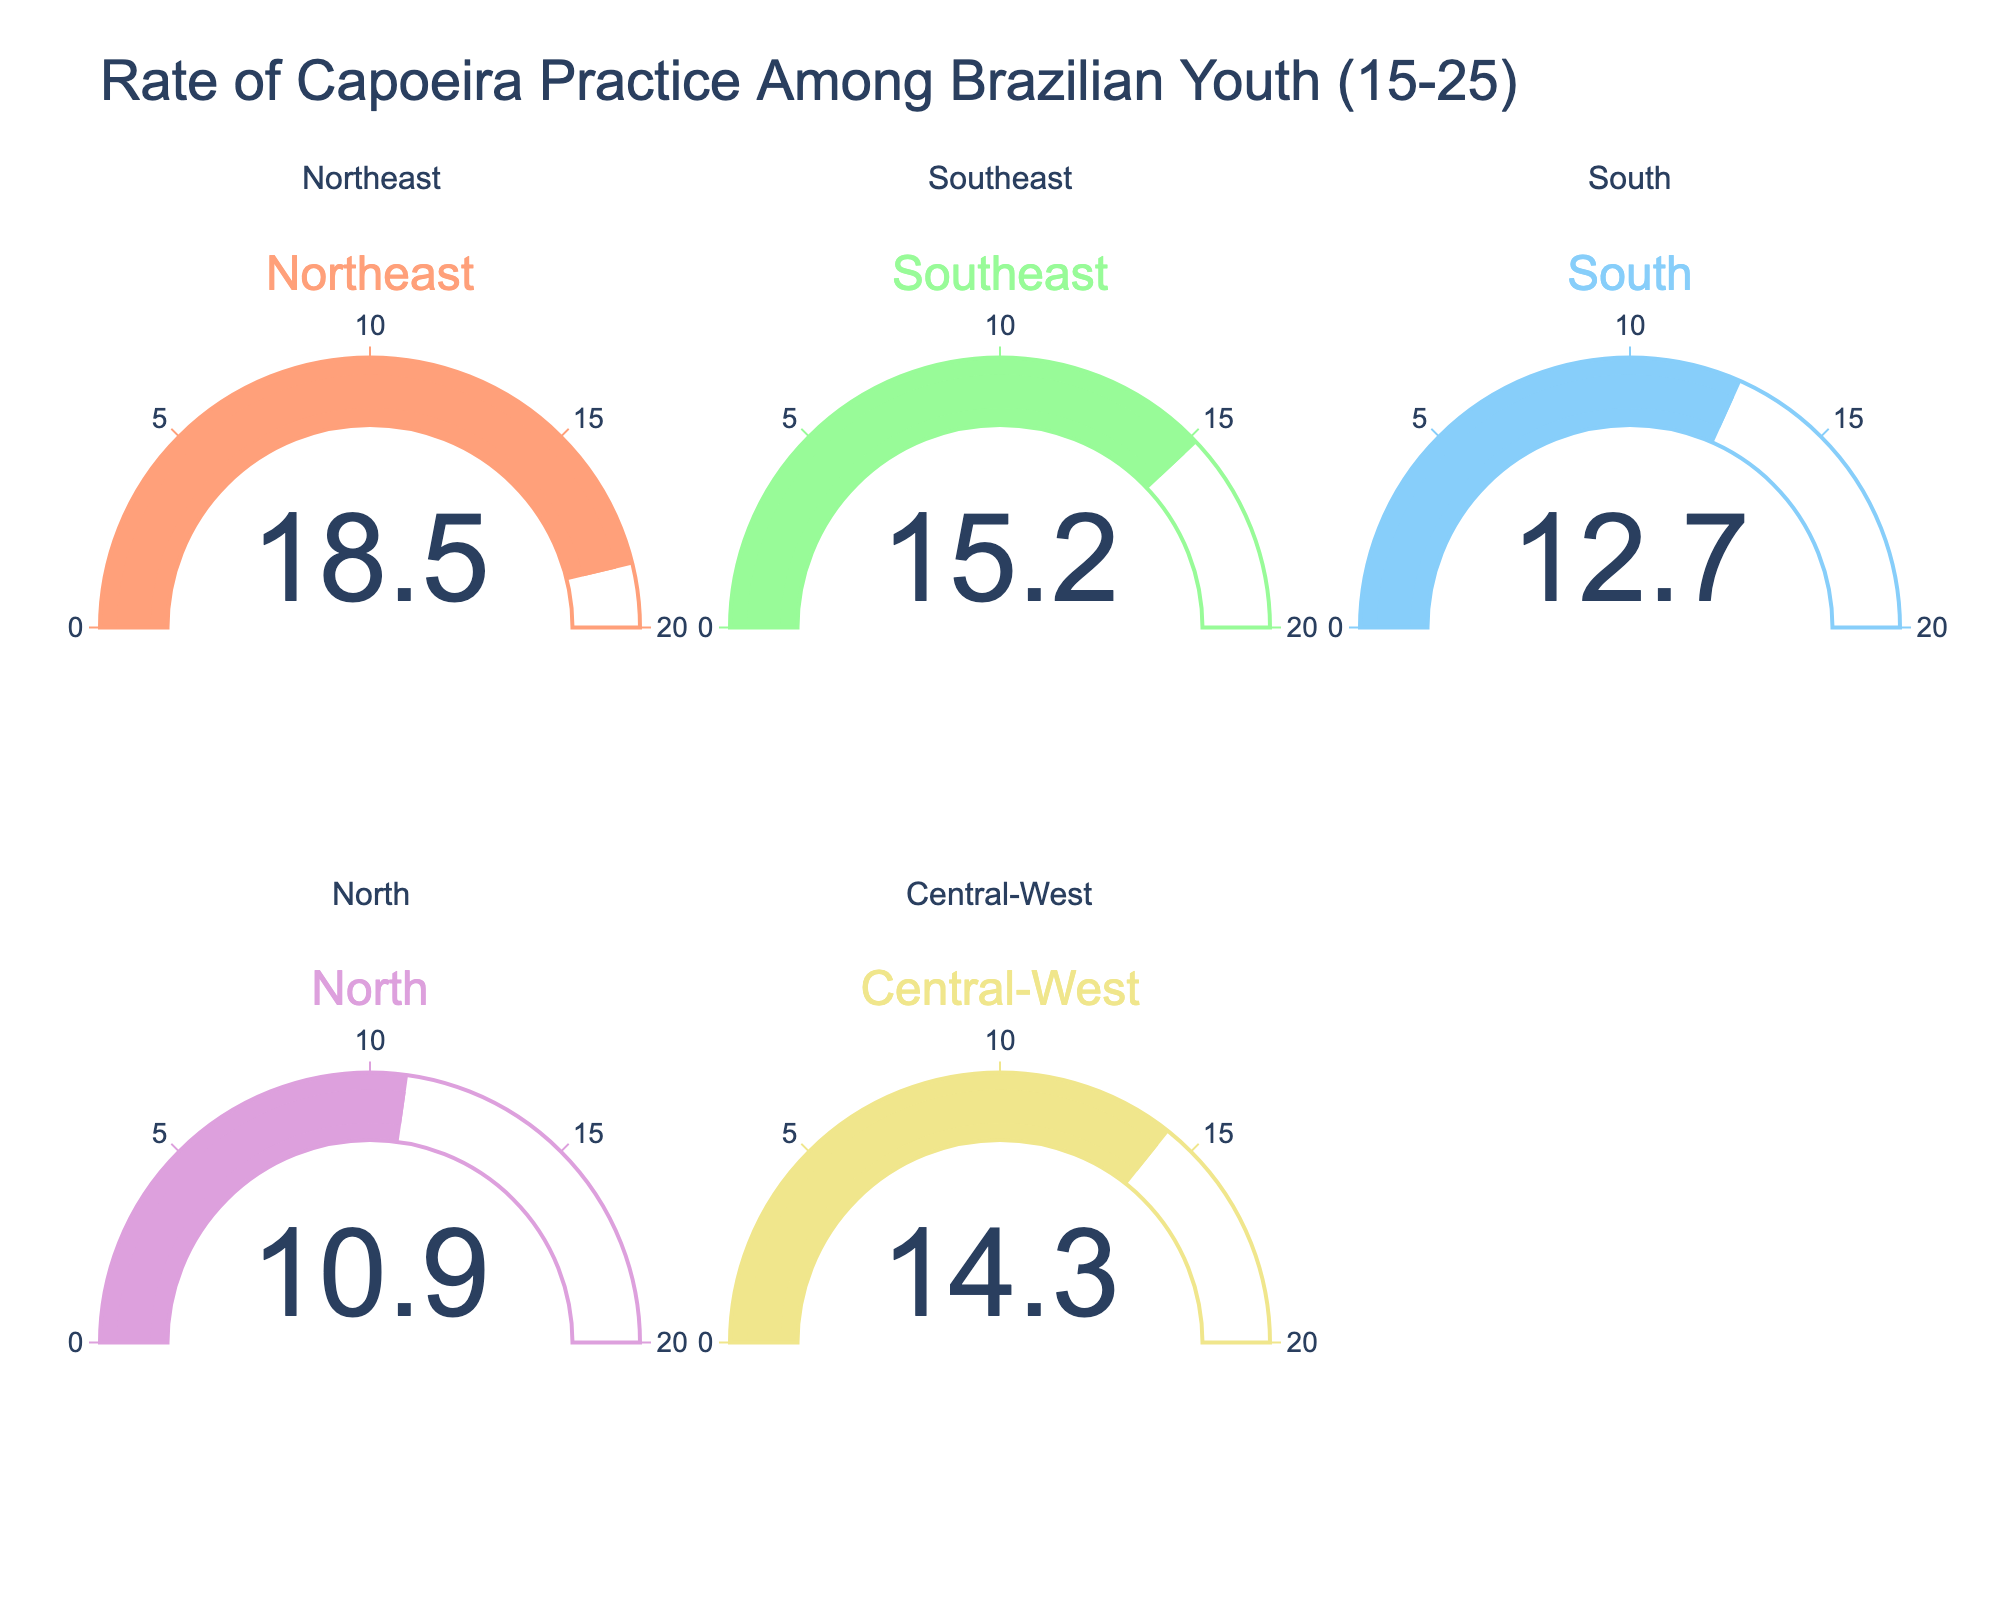What's the rate of capoeira practice among the Northeast region's youth aged 15-25? Refer to the gauge chart titled "Northeast" to find the value shown on the gauge.
Answer: 18.5 Which region has the lowest rate of capoeira practice among Brazilian youth aged 15-25? Compare the values on all gauges. The gauge for the North region has the lowest value.
Answer: North What is the average rate of capoeira practice among the youth in Southeast and Central-West regions? Add the rates (15.2 + 14.3) and then divide by 2. The calculation is (15.2 + 14.3)/2 = 14.75.
Answer: 14.75 How much higher is the rate of capoeira practice in the Northeast compared to the South region? Subtract the rate of South (12.7) from the rate of Northeast (18.5). The calculation is 18.5 - 12.7 = 5.8.
Answer: 5.8 Which region has a rate of capoeira practice closest to 15%? Compare the rates on all gauges to find the one closest to 15%. The Southeast region has a rate of 15.2%.
Answer: Southeast What is the combined rate of capoeira practice in the North and Central-West regions? Add the rates of North (10.9) and Central-West (14.3). The calculation is 10.9 + 14.3 = 25.2.
Answer: 25.2 Rank the regions from highest to lowest rate of capoeira practice among the youth. Compare all the regions' rates and then list them in descending order: Northeast (18.5), Southeast (15.2), Central-West (14.3), South (12.7), North (10.9).
Answer: Northeast, Southeast, Central-West, South, North What's the difference in the rate of capoeira practice between the Southeast and Central-West regions? Subtract the rate of Central-West (14.3) from the rate of Southeast (15.2). The calculation is 15.2 - 14.3 = 0.9.
Answer: 0.9 What's the average rate of capoeira practice across all regions? Add all the rates and then divide by the number of regions (5). Calculation: (18.5 + 15.2 + 12.7 + 10.9 + 14.3) / 5 = 14.32.
Answer: 14.32 